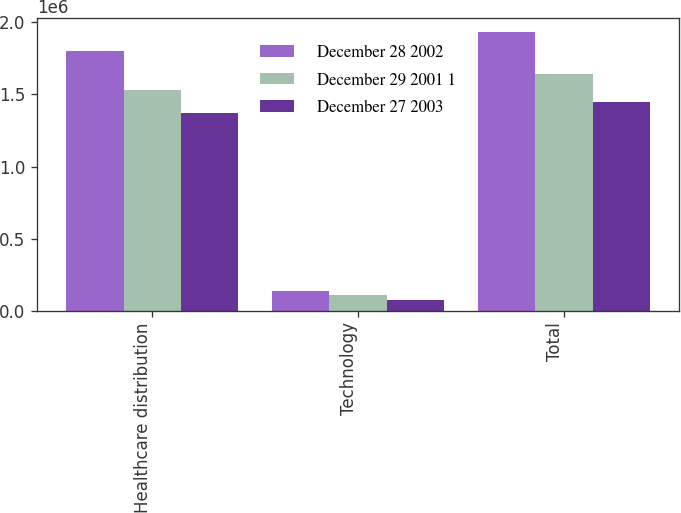Convert chart. <chart><loc_0><loc_0><loc_500><loc_500><stacked_bar_chart><ecel><fcel>Healthcare distribution<fcel>Technology<fcel>Total<nl><fcel>December 28 2002<fcel>1.79886e+06<fcel>134615<fcel>1.93347e+06<nl><fcel>December 29 2001 1<fcel>1.53353e+06<fcel>106319<fcel>1.63985e+06<nl><fcel>December 27 2003<fcel>1.36924e+06<fcel>75030<fcel>1.44427e+06<nl></chart> 